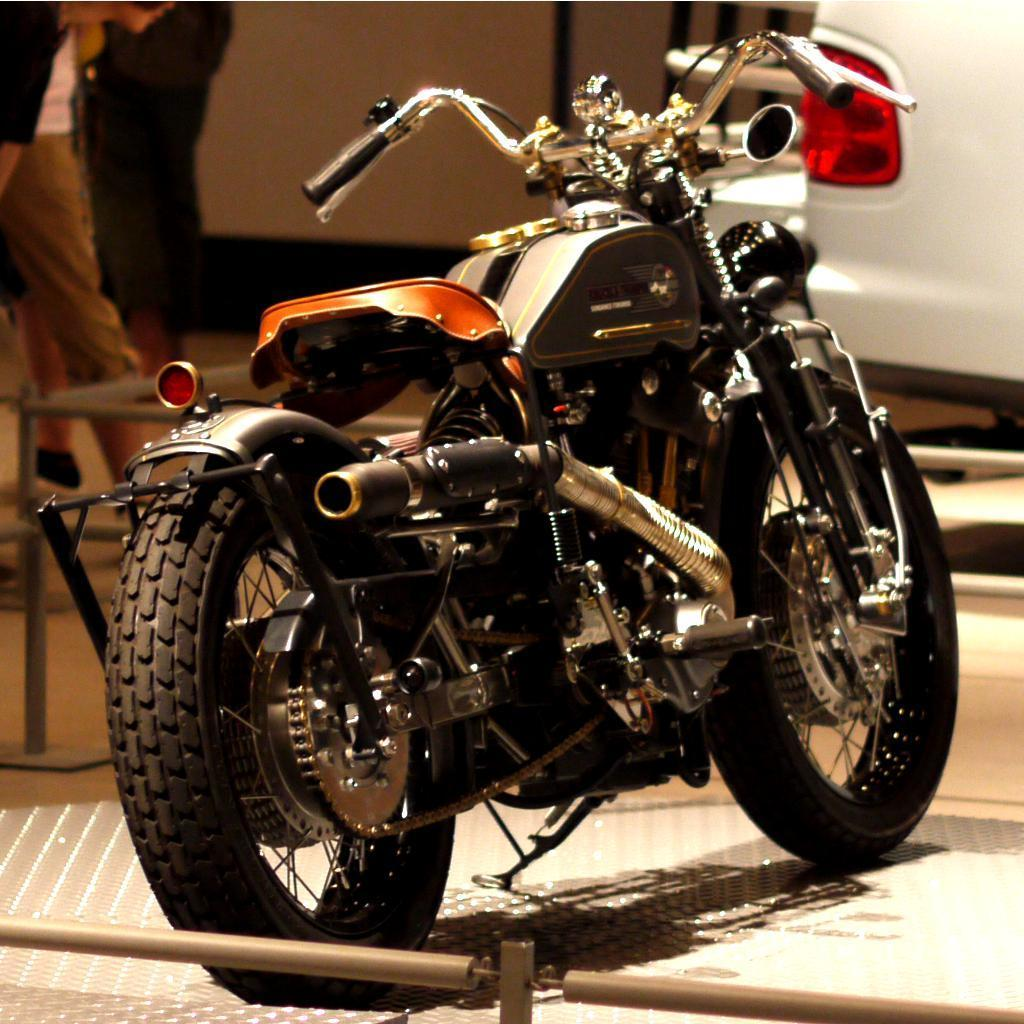What is the main object in the image? There is a bike in the image. How many people are in the image? There are two persons standing on the floor in the image. Where are the two persons located in relation to the bike? The two persons are on the left side of the bike. What type of fencing is in front of the bike? There is a fencing with iron in front of the bike. What type of table can be seen inside the cave in the image? There is no table or cave present in the image; it features a bike with two people and an iron fencing in front of it. 